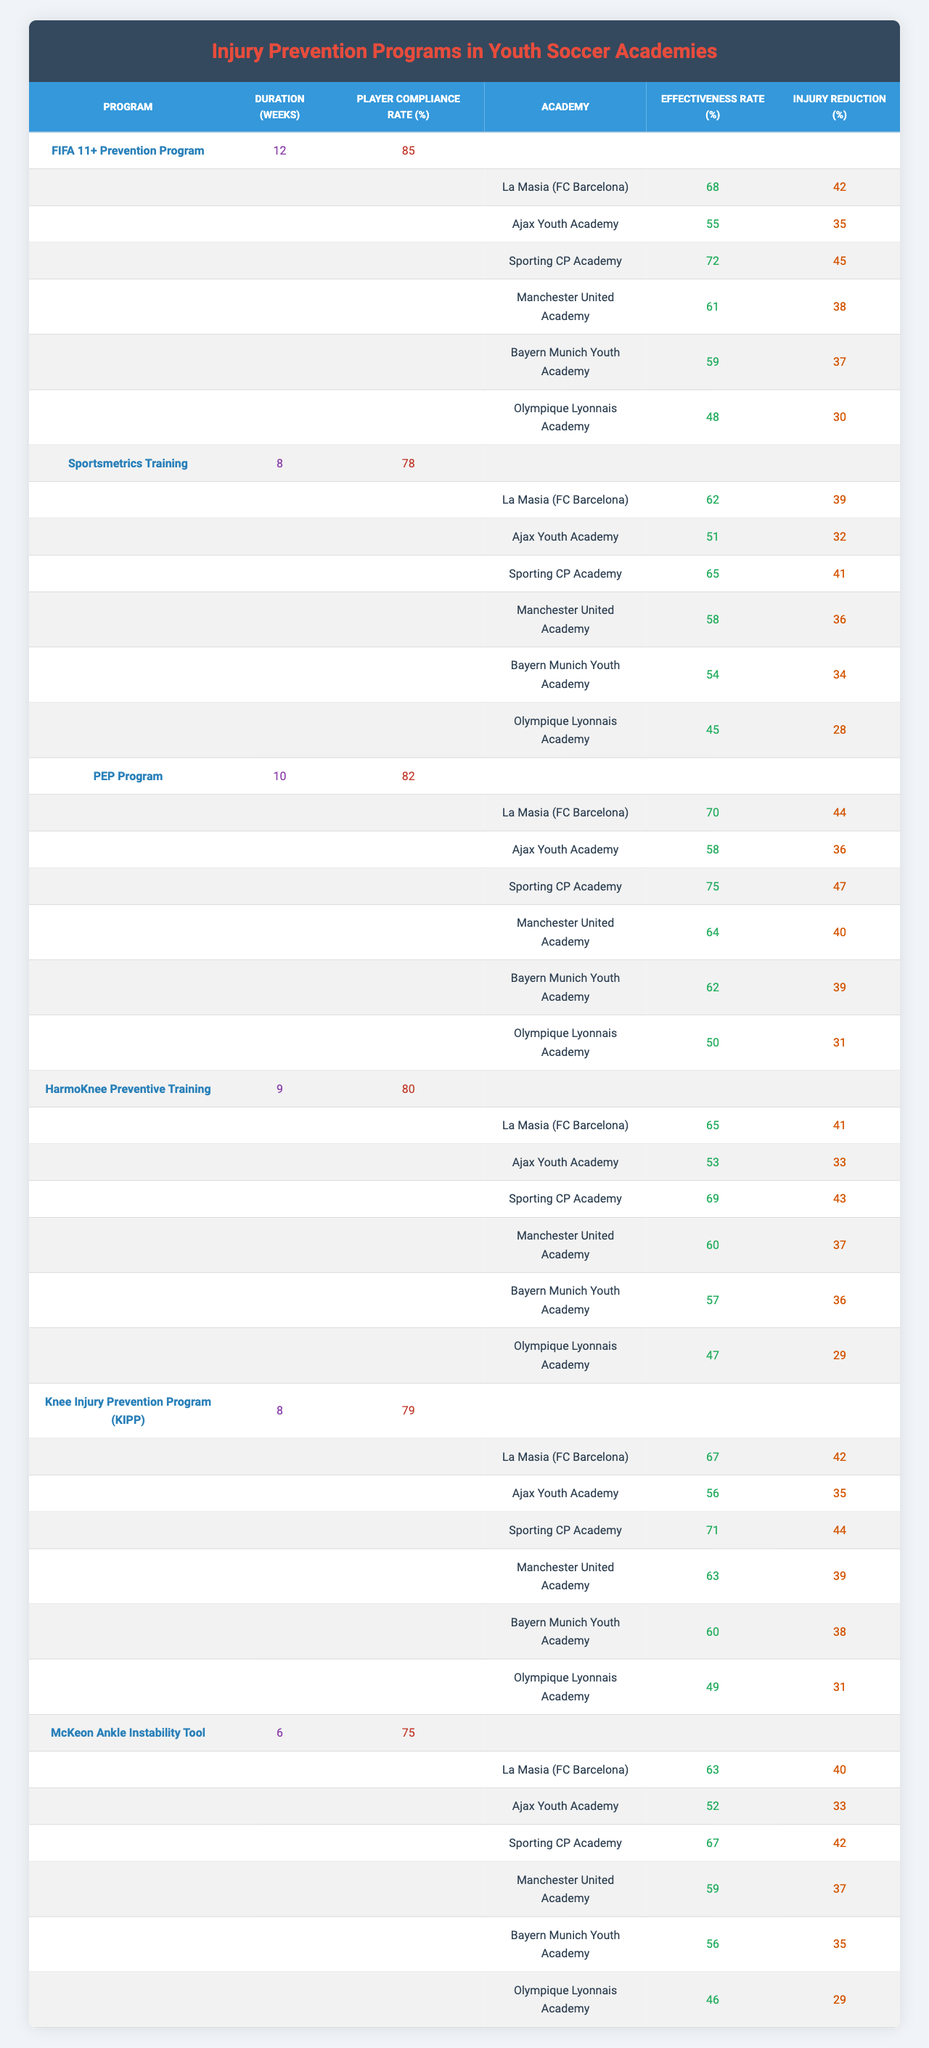What is the effectiveness rate of the FIFA 11+ Prevention Program at La Masia? The effectiveness rate for the FIFA 11+ Prevention Program, as listed for La Masia, is 68%.
Answer: 68% What is the program duration for the McKeon Ankle Instability Tool? According to the table, the program duration for the McKeon Ankle Instability Tool is 6 weeks.
Answer: 6 weeks Which program has the highest player compliance rate? The FIFA 11+ Prevention Program has the highest player compliance rate at 85%.
Answer: 85% What is the injury reduction percentage for the PEP Program at Bayern Munich Youth Academy? The injury reduction percentage for the PEP Program at Bayern Munich Youth Academy is 63%.
Answer: 63% How does the effectiveness rate of the HarmoKnee Preventive Training at Ajax compare to that at Sporting CP Academy? The effectiveness rate for HarmoKnee Preventive Training at Ajax is 53%, while at Sporting CP Academy it is 60%. Ajax's rate is lower than Sporting CP Academy's by 7%.
Answer: Lower by 7% What is the average effectiveness rate of the Knee Injury Prevention Program across all academies? To find the average, we sum the effectiveness rates for the Knee Injury Prevention Program (67 + 56 + 71 + 63 + 60 + 49 = 366) and divide by 6, yielding an average of 61.
Answer: 61 Is the injury reduction percentage for the Sportsmetrics Training program at Manchester United Academy higher than 36%? The injury reduction percentage for Sportsmetrics Training at Manchester United Academy is 36%, so it is not higher.
Answer: No Which academy had the lowest effectiveness rate for the HarmoKnee Preventive Training? The lowest effectiveness rate for HarmoKnee Preventive Training is at Olympique Lyonnais Academy, with a rate of 47%.
Answer: 47% If we add the effectiveness rates of the PEP Program for all academies, what is the total? The effectiveness rates for the PEP Program across the academies are (70 + 58 + 75 + 64 + 62 + 50 = 379), so the total is 379.
Answer: 379 Does the McKeon Ankle Instability Tool have a higher player compliance rate than the average compliance rate of all programs? The average player compliance rate is (85 + 78 + 82 + 80 + 79 + 75) / 6 = 79.67. The McKeon Ankle Instability Tool has a compliance rate of 75%, which is lower.
Answer: No What is the percentage difference in injury reduction between the FIFA 11+ Prevention Program and the Sportsmetrics Training at Ajax Youth Academy? The injury reduction for FIFA 11+ at Ajax is 35% and for Sportsmetrics is 32%. The difference is 35 - 32 = 3%, so FIFA 11+ is 3% better.
Answer: 3% 